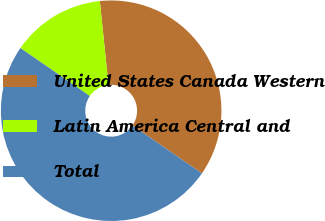Convert chart. <chart><loc_0><loc_0><loc_500><loc_500><pie_chart><fcel>United States Canada Western<fcel>Latin America Central and<fcel>Total<nl><fcel>36.26%<fcel>13.74%<fcel>50.0%<nl></chart> 